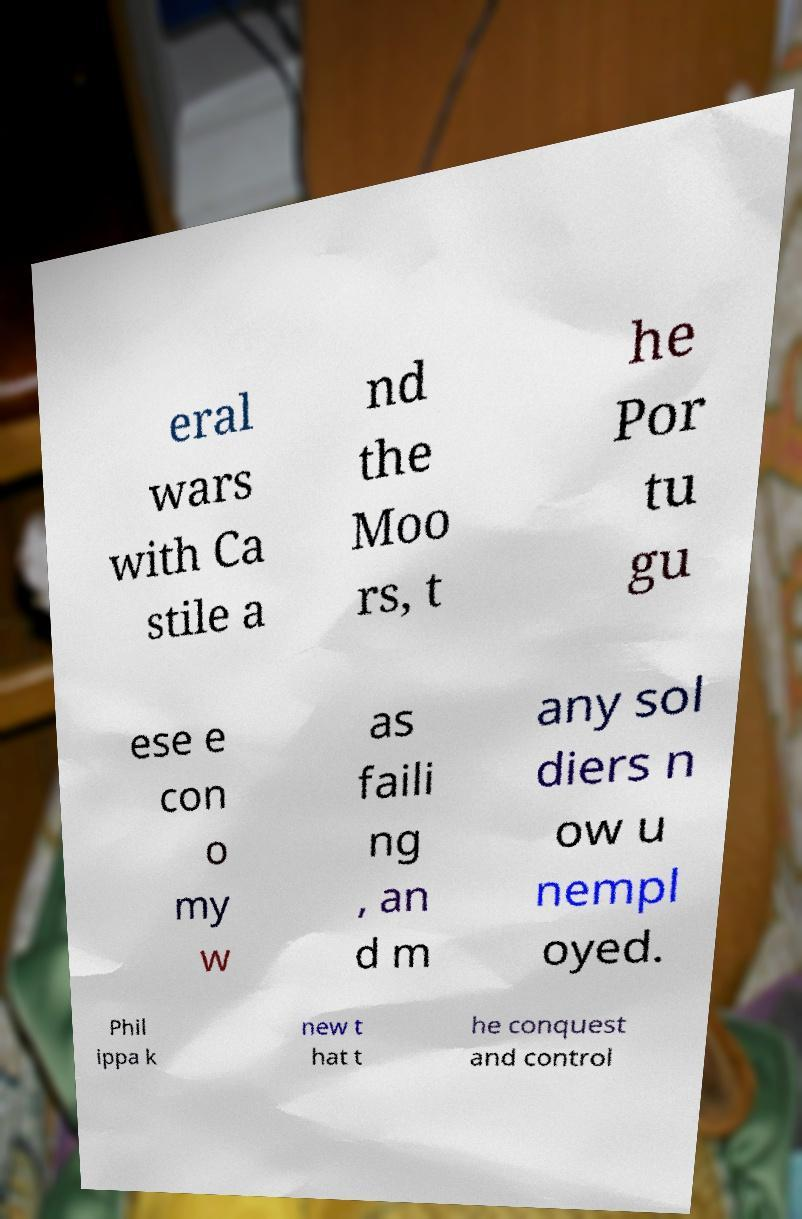Could you assist in decoding the text presented in this image and type it out clearly? eral wars with Ca stile a nd the Moo rs, t he Por tu gu ese e con o my w as faili ng , an d m any sol diers n ow u nempl oyed. Phil ippa k new t hat t he conquest and control 